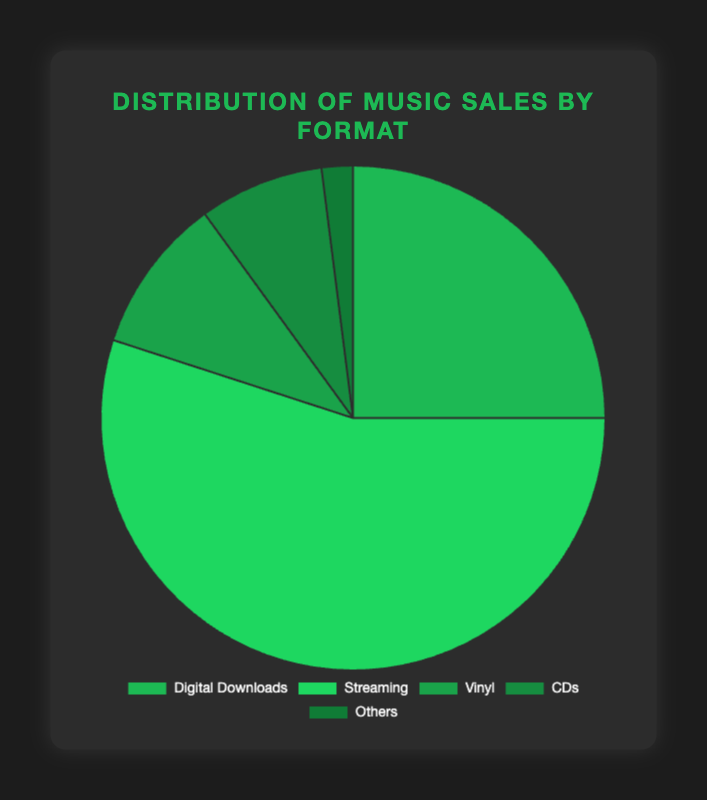What percentage of music sales do digital formats (Digital Downloads and Streaming) together account for? To find the percentage of digital formats, add the percentages for Digital Downloads (25%) and Streaming (55%). 25 + 55 = 80
Answer: 80% Which format has the highest percentage of music sales? The format with the highest percentage of music sales is the one with the largest slice in the pie chart. Streaming has the highest percentage at 55%
Answer: Streaming Which format has the lowest percentage of music sales? The format with the lowest percentage of music sales is the one with the smallest slice in the pie chart. Others has the lowest percentage at 2%
Answer: Others How many times larger is the percentage of music sales from Streaming compared to Vinyl? To find out how many times larger Streaming is compared to Vinyl, divide the percentage of Streaming (55%) by the percentage of Vinyl (10%). 55 / 10 = 5.5
Answer: 5.5 times Combined, do Vinyl and CDs make up more or less than Digital Downloads? To determine this, add the percentages for Vinyl (10%) and CDs (8%) together, then compare to Digital Downloads (25%). 10 + 8 = 18, which is less than 25
Answer: Less What is the difference in percentage points between the highest and the lowest music sales formats? Subtract the percentage of the format with the lowest sales (Others, 2%) from the percentage of the format with the highest sales (Streaming, 55%). 55 - 2 = 53
Answer: 53 Which formats together make up more than half of the total music sales? Only Streaming has a percentage greater than half (55%), as it is the only format above 50%
Answer: Streaming What is the combined percentage of Vinyl, CDs, and Others? Add the percentages for Vinyl (10%), CDs (8%), and Others (2%). 10 + 8 + 2 = 20
Answer: 20% If the CD sales doubled, what would be its new percentage, and would it surpass Digital Downloads? If CD sales doubled, its percentage would be 8% * 2 = 16%. Since 16% is still less than 25%, it would not surpass Digital Downloads
Answer: No Which format is closer in percentage to CDs, Vinyl or Others? The percentage of CDs is 8%. Comparing the proximity, Vinyl is 10% (difference of 2%) and Others is 2% (difference of 6%). Therefore, Vinyl is closer to CDs
Answer: Vinyl 